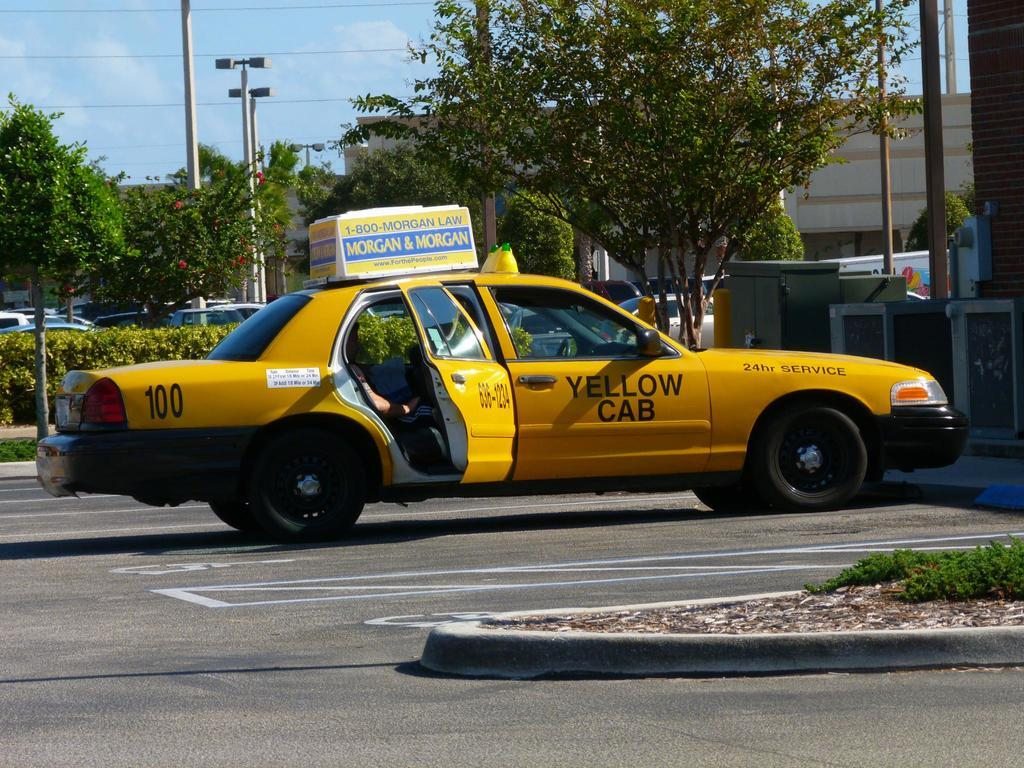<image>
Relay a brief, clear account of the picture shown. A parked yellow taxi cab which has the number 100 on it. 